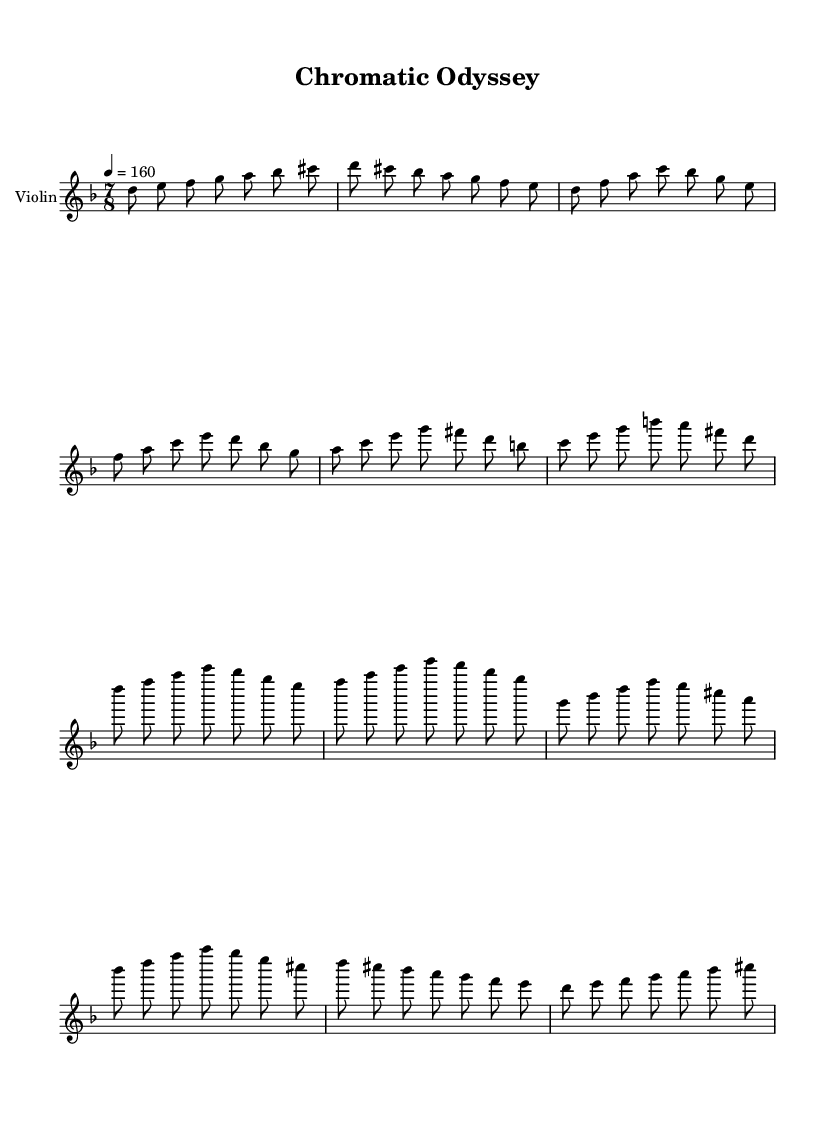What is the time signature of this music? The time signature is found next to the clef and is indicated as 7/8, which means there are seven eighth notes per measure.
Answer: 7/8 What is the key signature of this music? The key signature is represented by the two flats visible on the staff, indicating that the piece is in D minor.
Answer: D minor What is the tempo marking of this music? The tempo marking appears below the clef and indicates a speed of 4 beats per minute, which is set at 160.
Answer: 160 How many measures are in the chorus section? By counting the distinct segments enclosed within bars that correspond to the chorus's musical phrases, there are two measures present.
Answer: 2 Why is the use of 7/8 time signature significant in K-Pop? The 7/8 time signature introduces an unconventional rhythmic feel that can create a distinctive, layered texture in sections, making it stand out in a typically 4/4 genre like K-Pop. This complexity adds to the intricate arrangements associated with progressive metal influences.
Answer: Unique rhythmic feel How many notes are there in the intro melody? The intro section consists of 8 distinct notes that are played in the first bar, plus repeats of some notes in subsequent bars, making a total of 15 unique notes in that section.
Answer: 15 What influence do progressive metal elements have on this K-Pop piece? The introduction of progressive rock elements, such as complex time signatures and extended harmonies, expands the sonic palette and introduces more sophisticated arrangements that challenge typical K-Pop structures. This can appeal to a broader audience that appreciates intricate musicianship.
Answer: Complex arrangements 